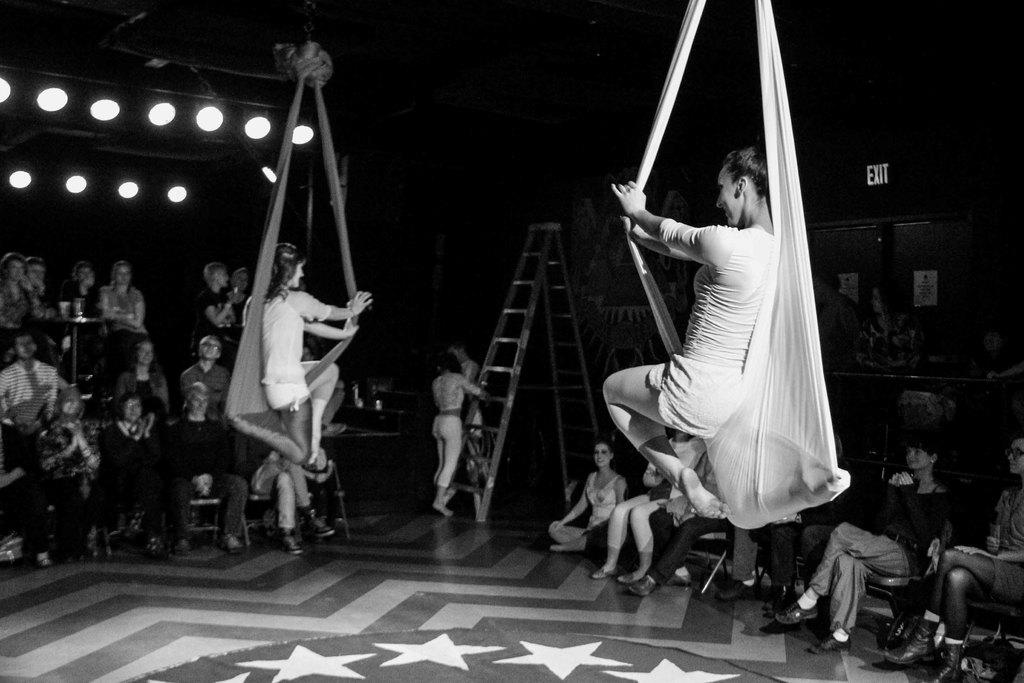What are the two people in the image doing? The two people in the image are hanging from cloth. What is the reaction of the other people in the image? There are many people sitting and watching in the image. How many passengers are on the boot in the image? There is no boot or passengers present in the image. 